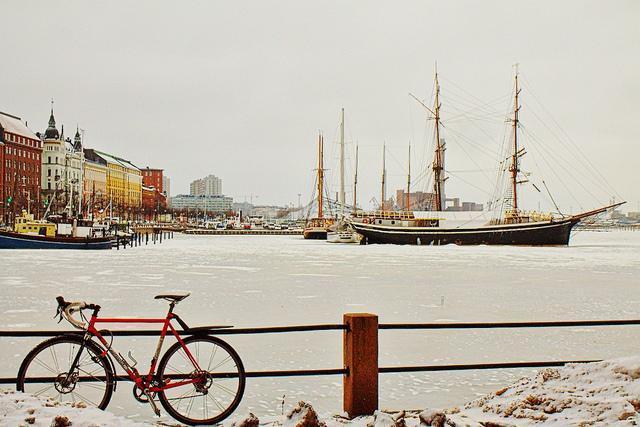How many boats are there?
Give a very brief answer. 2. 